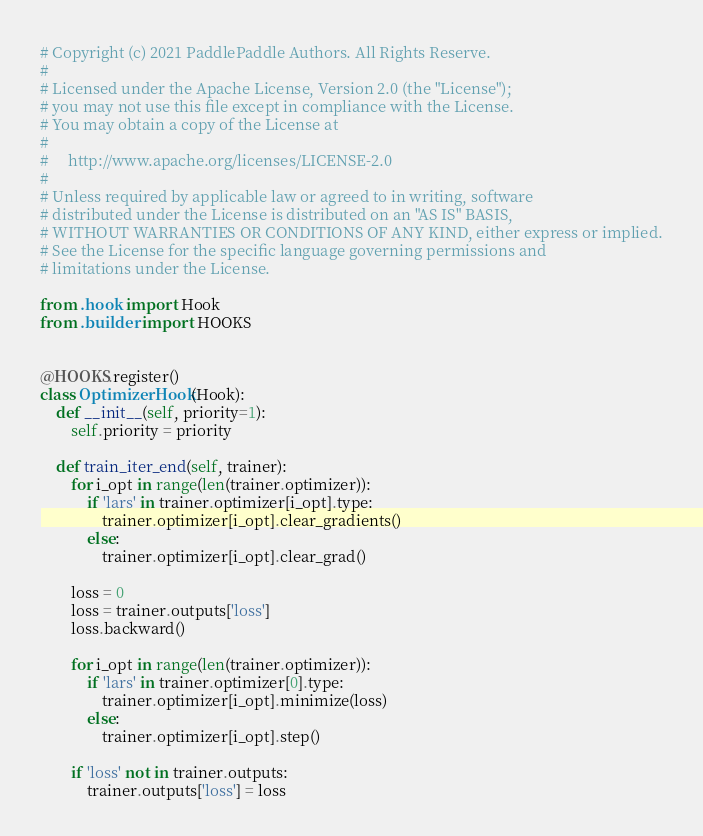<code> <loc_0><loc_0><loc_500><loc_500><_Python_># Copyright (c) 2021 PaddlePaddle Authors. All Rights Reserve.
#
# Licensed under the Apache License, Version 2.0 (the "License");
# you may not use this file except in compliance with the License.
# You may obtain a copy of the License at
#
#     http://www.apache.org/licenses/LICENSE-2.0
#
# Unless required by applicable law or agreed to in writing, software
# distributed under the License is distributed on an "AS IS" BASIS,
# WITHOUT WARRANTIES OR CONDITIONS OF ANY KIND, either express or implied.
# See the License for the specific language governing permissions and
# limitations under the License.

from .hook import Hook
from .builder import HOOKS


@HOOKS.register()
class OptimizerHook(Hook):
    def __init__(self, priority=1):
        self.priority = priority
        
    def train_iter_end(self, trainer):
        for i_opt in range(len(trainer.optimizer)):
            if 'lars' in trainer.optimizer[i_opt].type:
                trainer.optimizer[i_opt].clear_gradients()
            else:
                trainer.optimizer[i_opt].clear_grad()

        loss = 0
        loss = trainer.outputs['loss']
        loss.backward()
        
        for i_opt in range(len(trainer.optimizer)):
            if 'lars' in trainer.optimizer[0].type:
                trainer.optimizer[i_opt].minimize(loss)
            else:
                trainer.optimizer[i_opt].step()

        if 'loss' not in trainer.outputs:
            trainer.outputs['loss'] = loss
</code> 